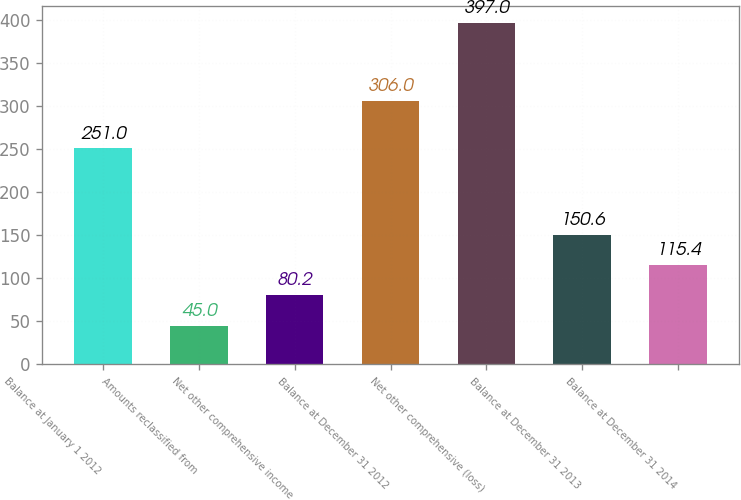Convert chart to OTSL. <chart><loc_0><loc_0><loc_500><loc_500><bar_chart><fcel>Balance at January 1 2012<fcel>Amounts reclassified from<fcel>Net other comprehensive income<fcel>Balance at December 31 2012<fcel>Net other comprehensive (loss)<fcel>Balance at December 31 2013<fcel>Balance at December 31 2014<nl><fcel>251<fcel>45<fcel>80.2<fcel>306<fcel>397<fcel>150.6<fcel>115.4<nl></chart> 